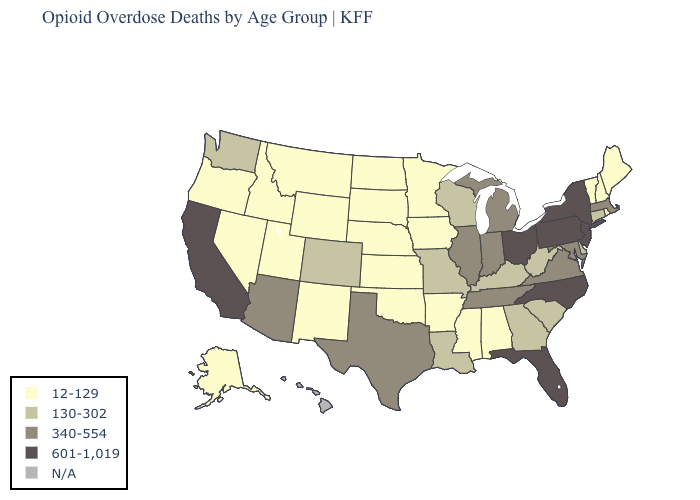Which states have the lowest value in the South?
Write a very short answer. Alabama, Arkansas, Mississippi, Oklahoma. What is the value of Illinois?
Answer briefly. 340-554. Name the states that have a value in the range 12-129?
Quick response, please. Alabama, Alaska, Arkansas, Idaho, Iowa, Kansas, Maine, Minnesota, Mississippi, Montana, Nebraska, Nevada, New Hampshire, New Mexico, North Dakota, Oklahoma, Oregon, Rhode Island, South Dakota, Utah, Vermont, Wyoming. What is the highest value in the South ?
Quick response, please. 601-1,019. Among the states that border Pennsylvania , does West Virginia have the lowest value?
Write a very short answer. Yes. What is the value of North Carolina?
Concise answer only. 601-1,019. What is the value of Georgia?
Keep it brief. 130-302. What is the highest value in states that border Michigan?
Answer briefly. 601-1,019. What is the highest value in the Northeast ?
Keep it brief. 601-1,019. Name the states that have a value in the range 340-554?
Keep it brief. Arizona, Illinois, Indiana, Maryland, Massachusetts, Michigan, Tennessee, Texas, Virginia. Does the first symbol in the legend represent the smallest category?
Quick response, please. Yes. What is the lowest value in the MidWest?
Short answer required. 12-129. Does Ohio have the highest value in the MidWest?
Be succinct. Yes. Does Michigan have the lowest value in the USA?
Quick response, please. No. What is the highest value in the USA?
Short answer required. 601-1,019. 